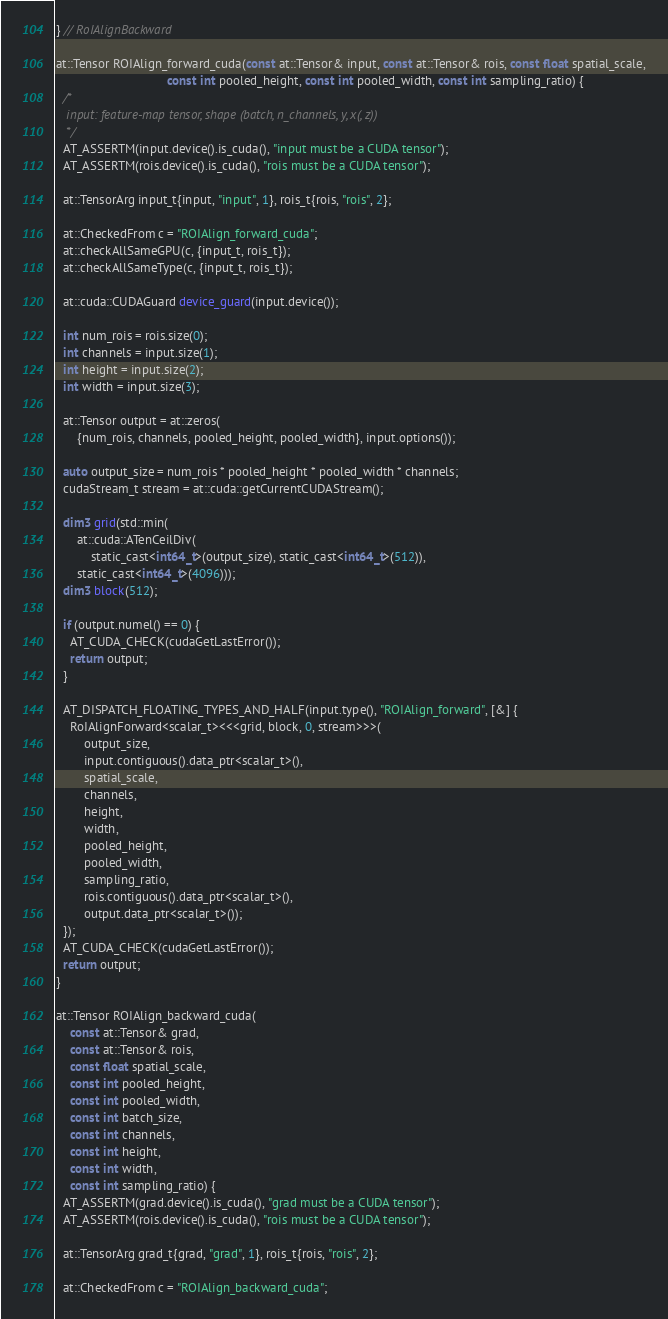Convert code to text. <code><loc_0><loc_0><loc_500><loc_500><_Cuda_>} // RoIAlignBackward

at::Tensor ROIAlign_forward_cuda(const at::Tensor& input, const at::Tensor& rois, const float spatial_scale,
                                const int pooled_height, const int pooled_width, const int sampling_ratio) {
  /*
   input: feature-map tensor, shape (batch, n_channels, y, x(, z))
   */
  AT_ASSERTM(input.device().is_cuda(), "input must be a CUDA tensor");
  AT_ASSERTM(rois.device().is_cuda(), "rois must be a CUDA tensor");

  at::TensorArg input_t{input, "input", 1}, rois_t{rois, "rois", 2};

  at::CheckedFrom c = "ROIAlign_forward_cuda";
  at::checkAllSameGPU(c, {input_t, rois_t});
  at::checkAllSameType(c, {input_t, rois_t});

  at::cuda::CUDAGuard device_guard(input.device());

  int num_rois = rois.size(0);
  int channels = input.size(1);
  int height = input.size(2);
  int width = input.size(3);

  at::Tensor output = at::zeros(
      {num_rois, channels, pooled_height, pooled_width}, input.options());

  auto output_size = num_rois * pooled_height * pooled_width * channels;
  cudaStream_t stream = at::cuda::getCurrentCUDAStream();

  dim3 grid(std::min(
      at::cuda::ATenCeilDiv(
          static_cast<int64_t>(output_size), static_cast<int64_t>(512)),
      static_cast<int64_t>(4096)));
  dim3 block(512);

  if (output.numel() == 0) {
    AT_CUDA_CHECK(cudaGetLastError());
    return output;
  }

  AT_DISPATCH_FLOATING_TYPES_AND_HALF(input.type(), "ROIAlign_forward", [&] {
    RoIAlignForward<scalar_t><<<grid, block, 0, stream>>>(
        output_size,
        input.contiguous().data_ptr<scalar_t>(),
        spatial_scale,
        channels,
        height,
        width,
        pooled_height,
        pooled_width,
        sampling_ratio,
        rois.contiguous().data_ptr<scalar_t>(),
        output.data_ptr<scalar_t>());
  });
  AT_CUDA_CHECK(cudaGetLastError());
  return output;
}

at::Tensor ROIAlign_backward_cuda(
    const at::Tensor& grad,
    const at::Tensor& rois,
    const float spatial_scale,
    const int pooled_height,
    const int pooled_width,
    const int batch_size,
    const int channels,
    const int height,
    const int width,
    const int sampling_ratio) {
  AT_ASSERTM(grad.device().is_cuda(), "grad must be a CUDA tensor");
  AT_ASSERTM(rois.device().is_cuda(), "rois must be a CUDA tensor");

  at::TensorArg grad_t{grad, "grad", 1}, rois_t{rois, "rois", 2};

  at::CheckedFrom c = "ROIAlign_backward_cuda";</code> 